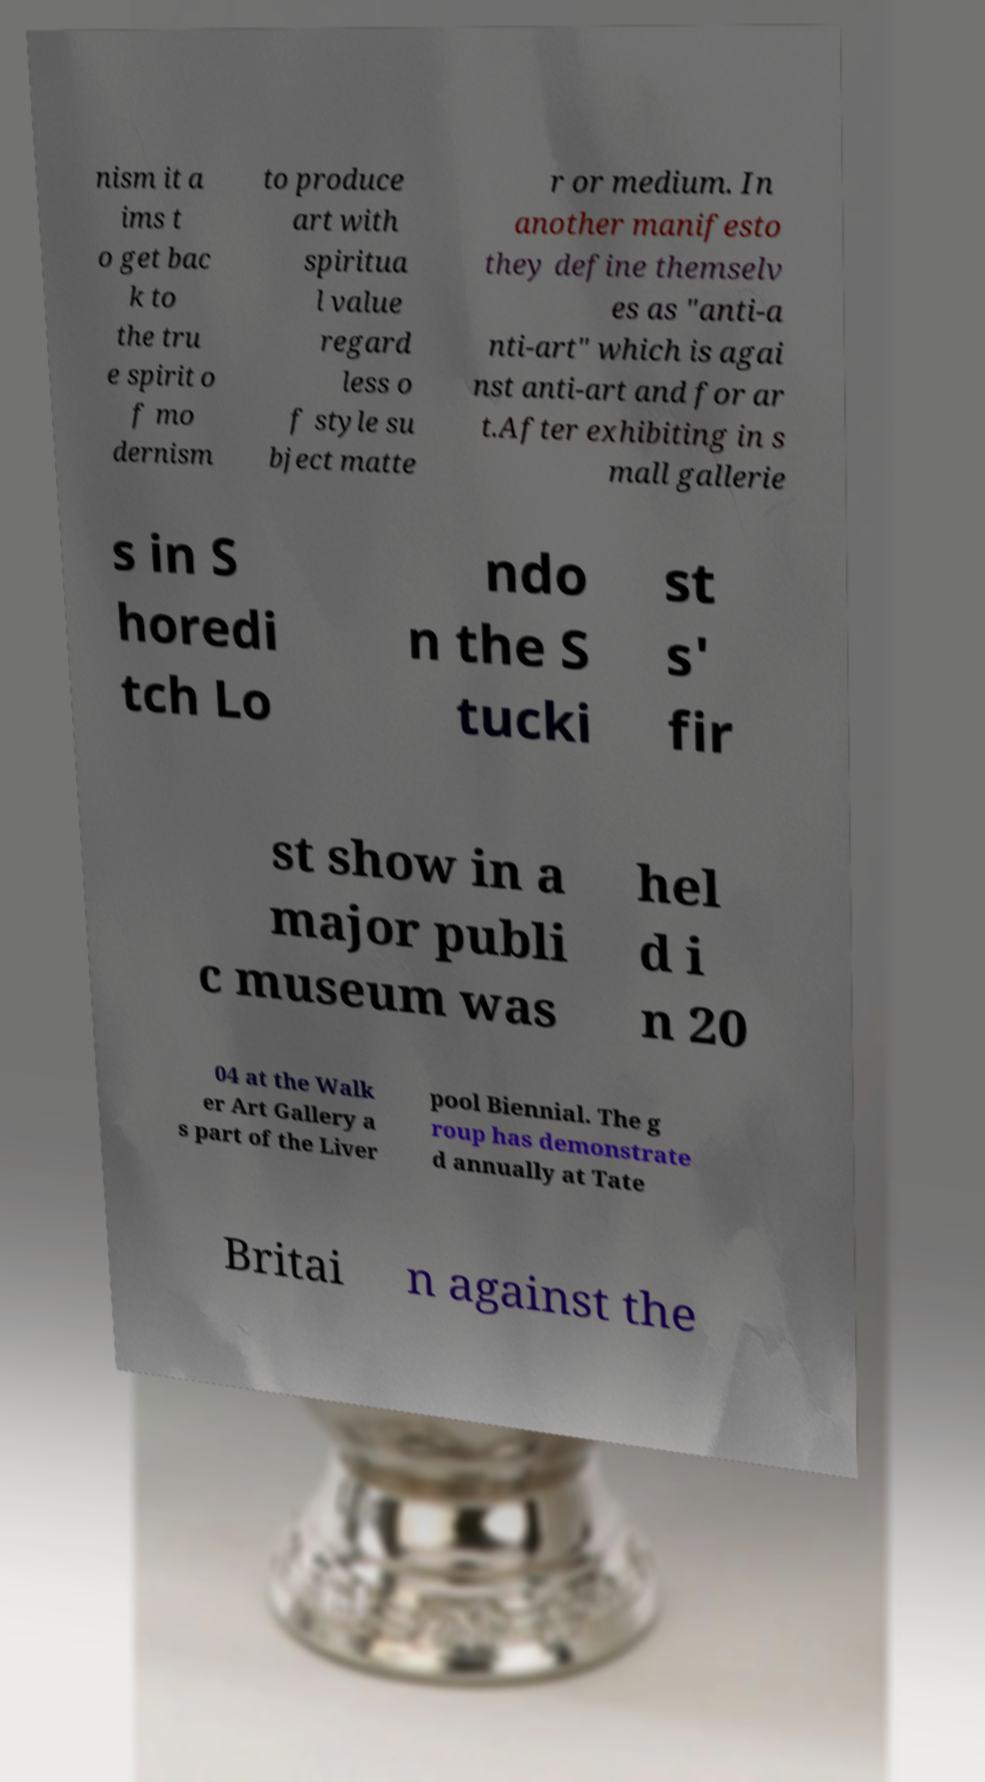I need the written content from this picture converted into text. Can you do that? nism it a ims t o get bac k to the tru e spirit o f mo dernism to produce art with spiritua l value regard less o f style su bject matte r or medium. In another manifesto they define themselv es as "anti-a nti-art" which is agai nst anti-art and for ar t.After exhibiting in s mall gallerie s in S horedi tch Lo ndo n the S tucki st s' fir st show in a major publi c museum was hel d i n 20 04 at the Walk er Art Gallery a s part of the Liver pool Biennial. The g roup has demonstrate d annually at Tate Britai n against the 